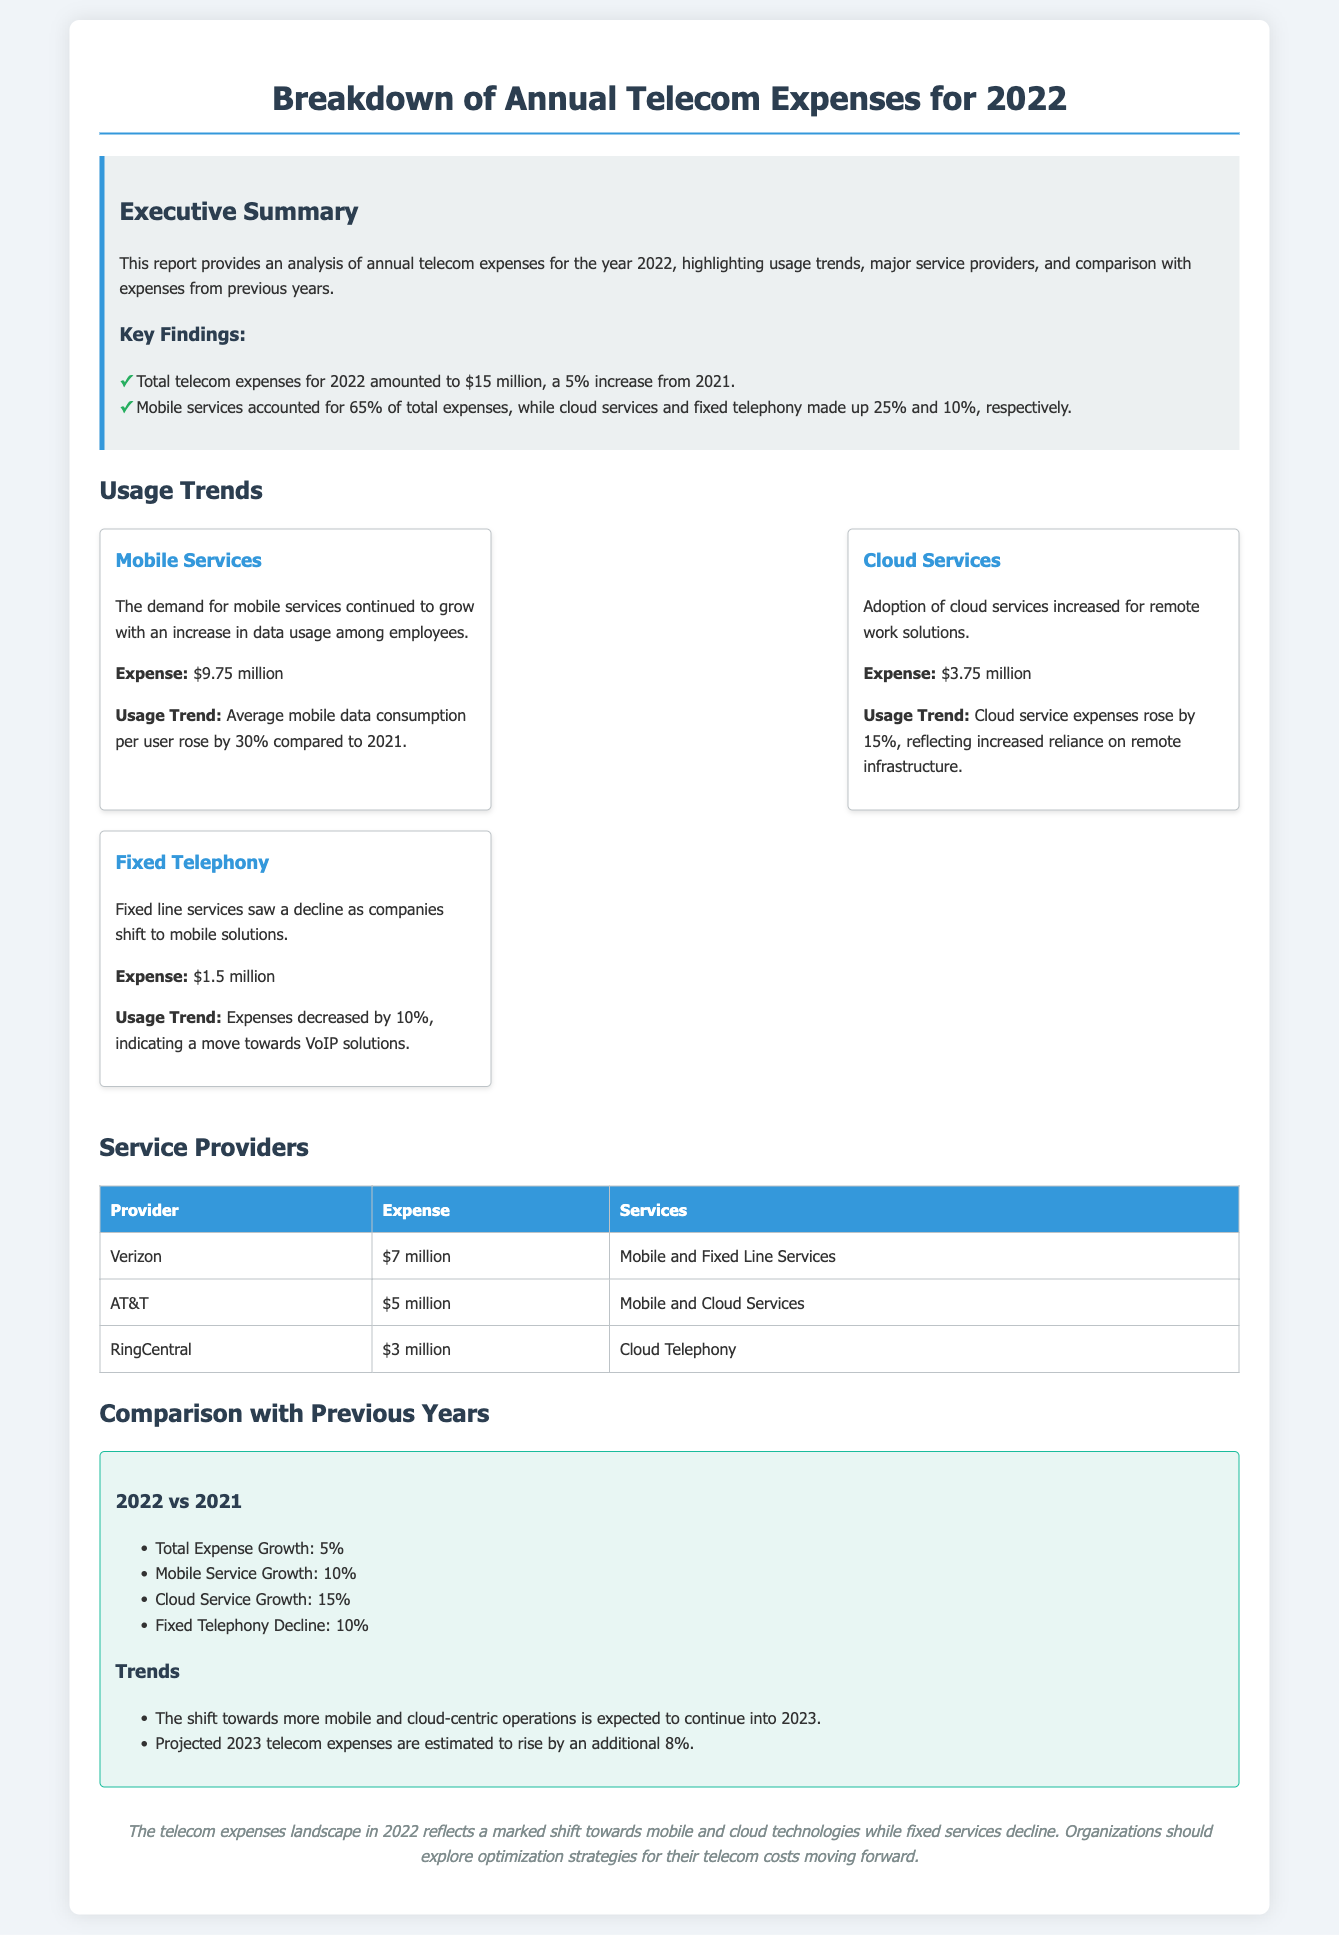What was the total telecom expense for 2022? The total telecom expense for 2022 is specifically mentioned in the executive summary section of the document as $15 million.
Answer: $15 million What percentage of total expenses was attributed to mobile services? The document states that mobile services accounted for 65% of total expenses, which is highlighted in the key findings.
Answer: 65% What service had the highest expense in 2022? The expenses breakdown identifies mobile services as the highest, with an expense of $9.75 million in the usage trends section.
Answer: Mobile Services Which provider had the lowest expense? The providers table indicates that RingCentral had the lowest expense at $3 million.
Answer: RingCentral What is the projected increase in telecom expenses for 2023? The document forecasts an estimated rise of 8% in telecom expenses for 2023 in the comparison section.
Answer: 8% How much did fixed telephony expenses decrease by compared to 2021? The comparison with previous years indicates that fixed telephony expenses decreased by 10% in 2022.
Answer: 10% What was the expense for cloud services in 2022? The usage trends section specifies that the expense for cloud services was $3.75 million.
Answer: $3.75 million What trend is observed in mobile services usage? The usage trends section highlights that average mobile data consumption per user rose by 30% compared to 2021.
Answer: 30% 